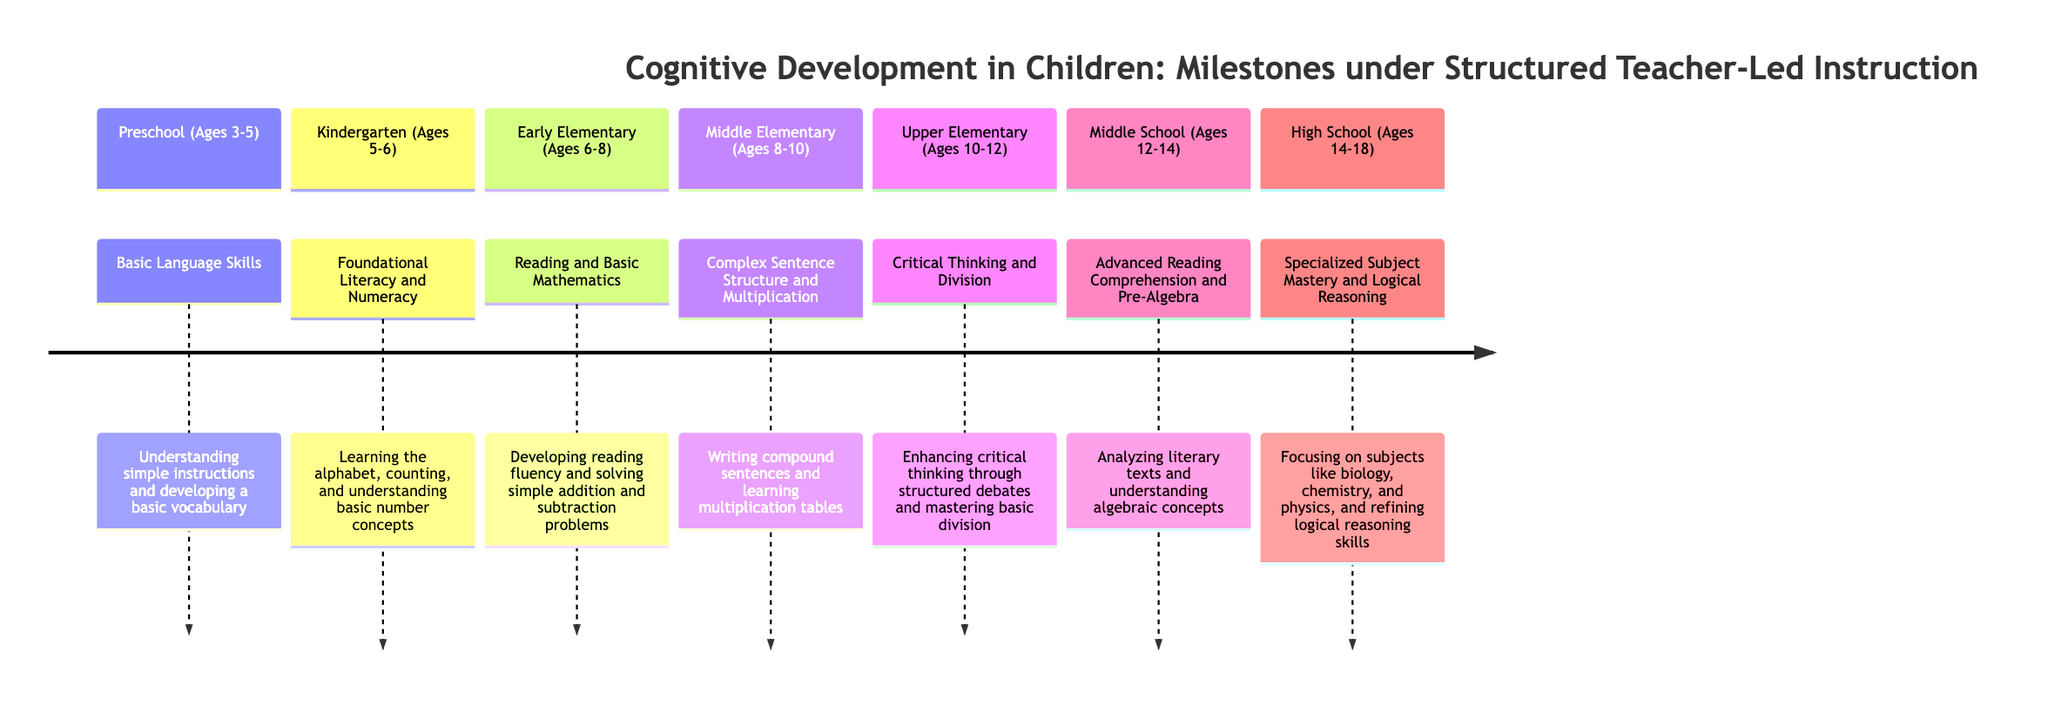What is the first milestone listed in the timeline? The first milestone is "Basic Language Skills," which is achieved during the Preschool age range.
Answer: Basic Language Skills At what age do children learn foundational literacy and numeracy? Foundational literacy and numeracy are learned at Kindergarten, which is for ages 5-6.
Answer: Ages 5-6 What key skill is developed during the Early Elementary stage? In Early Elementary, the key skill developed is "Reading and Basic Mathematics."
Answer: Reading and Basic Mathematics How many sections are outlined in the timeline? The timeline outlines 7 sections, representing different age ranges from preschool to high school.
Answer: 7 Which milestone occurs at ages 10-12? The milestone at ages 10-12 is "Critical Thinking and Division."
Answer: Critical Thinking and Division What type of reasoning skills are refined in High School? In High School, students focus on refining "Logical Reasoning" skills.
Answer: Logical Reasoning What age range corresponds to the milestone involving specialized subject mastery? Specialized subject mastery occurs during the High School age range, which is from ages 14-18.
Answer: Ages 14-18 What educational approach is suggested by the milestones outlined in the diagram? The milestones emphasize "Structured Teacher-Led Instruction" to achieve cognitive development.
Answer: Structured Teacher-Led Instruction Which milestone includes learning multiplication tables? The milestone that includes learning multiplication tables is "Complex Sentence Structure and Multiplication" at ages 8-10.
Answer: Complex Sentence Structure and Multiplication 